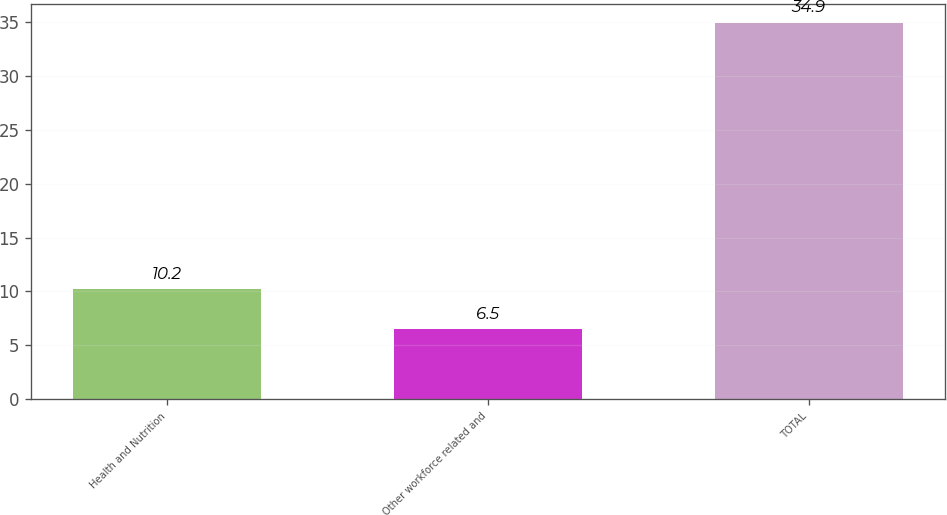Convert chart. <chart><loc_0><loc_0><loc_500><loc_500><bar_chart><fcel>Health and Nutrition<fcel>Other workforce related and<fcel>TOTAL<nl><fcel>10.2<fcel>6.5<fcel>34.9<nl></chart> 